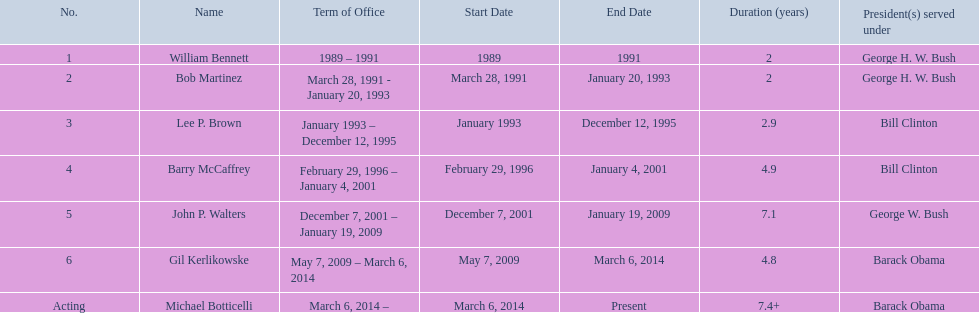Write the full table. {'header': ['No.', 'Name', 'Term of Office', 'Start Date', 'End Date', 'Duration (years)', 'President(s) served under'], 'rows': [['1', 'William Bennett', '1989 – 1991', '1989', '1991', '2', 'George H. W. Bush'], ['2', 'Bob Martinez', 'March 28, 1991 - January 20, 1993', 'March 28, 1991', 'January 20, 1993', '2', 'George H. W. Bush'], ['3', 'Lee P. Brown', 'January 1993 – December 12, 1995', 'January 1993', 'December 12, 1995', '2.9', 'Bill Clinton'], ['4', 'Barry McCaffrey', 'February 29, 1996 – January 4, 2001', 'February 29, 1996', 'January 4, 2001', '4.9', 'Bill Clinton'], ['5', 'John P. Walters', 'December 7, 2001 – January 19, 2009', 'December 7, 2001', 'January 19, 2009', '7.1', 'George W. Bush'], ['6', 'Gil Kerlikowske', 'May 7, 2009 – March 6, 2014', 'May 7, 2009', 'March 6, 2014', '4.8', 'Barack Obama'], ['Acting', 'Michael Botticelli', 'March 6, 2014 –', 'March 6, 2014', 'Present', '7.4+', 'Barack Obama']]} How many directors served more than 3 years? 3. 